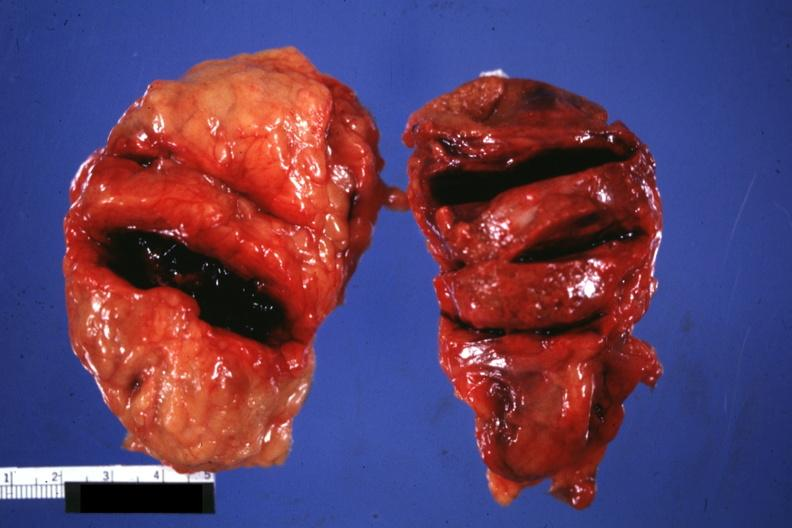what is present?
Answer the question using a single word or phrase. Adrenal 